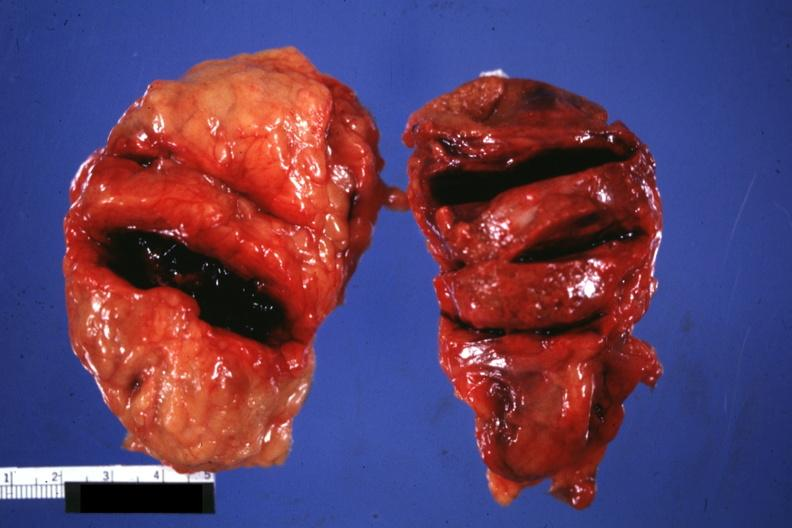what is present?
Answer the question using a single word or phrase. Adrenal 